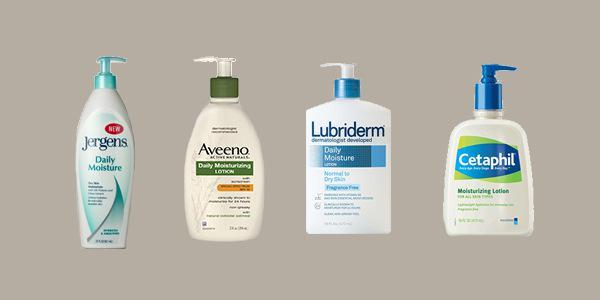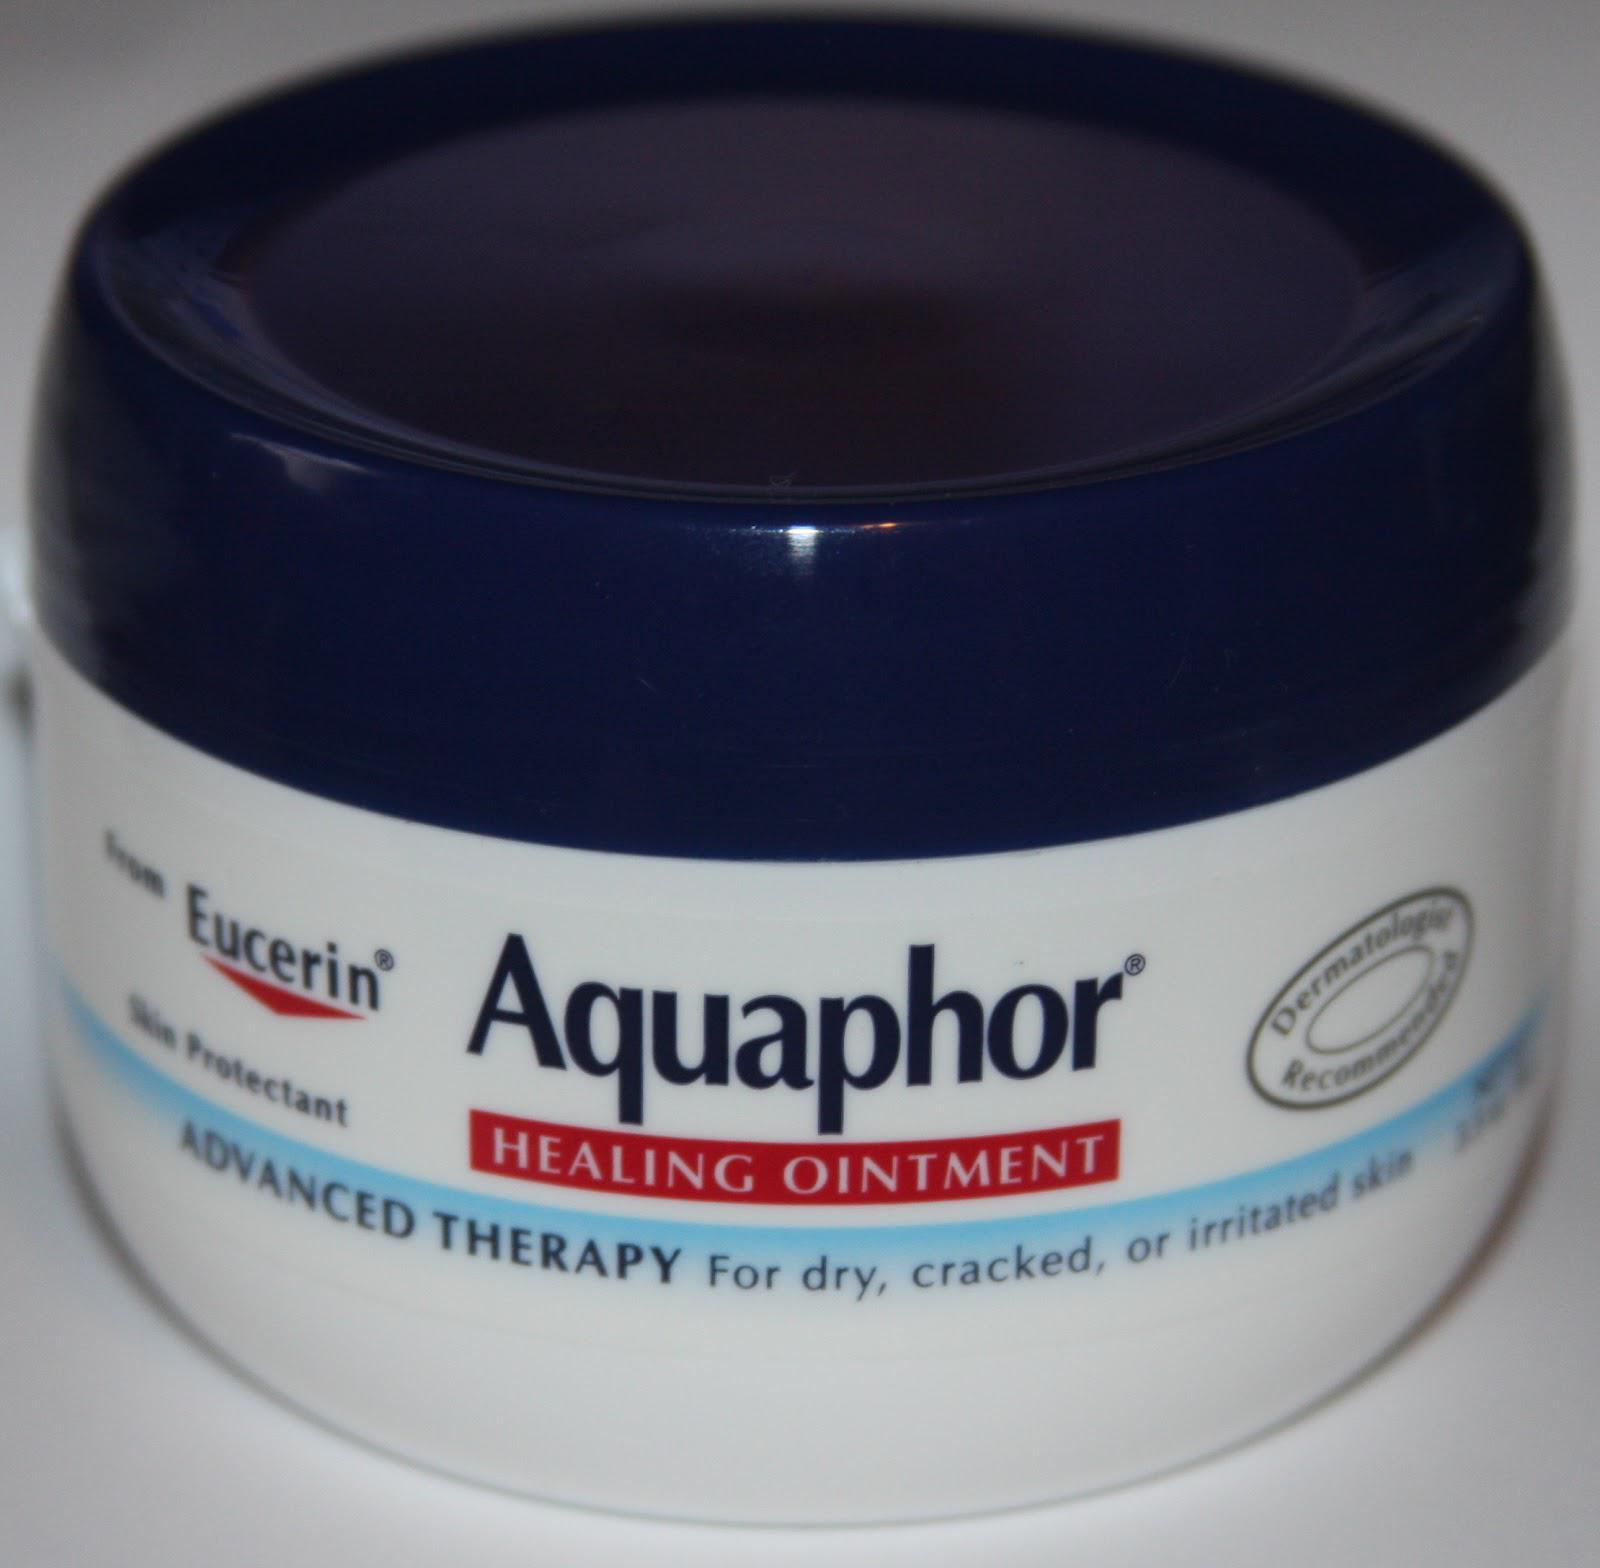The first image is the image on the left, the second image is the image on the right. Considering the images on both sides, is "At least one image contains red markings on the package." valid? Answer yes or no. Yes. 